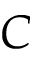Convert formula to latex. <formula><loc_0><loc_0><loc_500><loc_500>C</formula> 